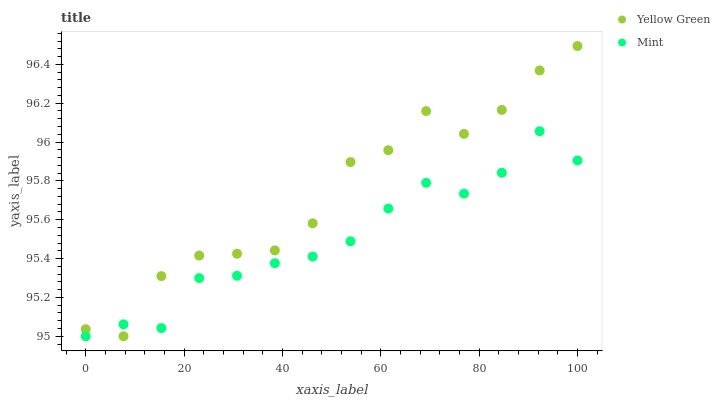Does Mint have the minimum area under the curve?
Answer yes or no. Yes. Does Yellow Green have the maximum area under the curve?
Answer yes or no. Yes. Does Yellow Green have the minimum area under the curve?
Answer yes or no. No. Is Mint the smoothest?
Answer yes or no. Yes. Is Yellow Green the roughest?
Answer yes or no. Yes. Is Yellow Green the smoothest?
Answer yes or no. No. Does Mint have the lowest value?
Answer yes or no. Yes. Does Yellow Green have the highest value?
Answer yes or no. Yes. Does Mint intersect Yellow Green?
Answer yes or no. Yes. Is Mint less than Yellow Green?
Answer yes or no. No. Is Mint greater than Yellow Green?
Answer yes or no. No. 